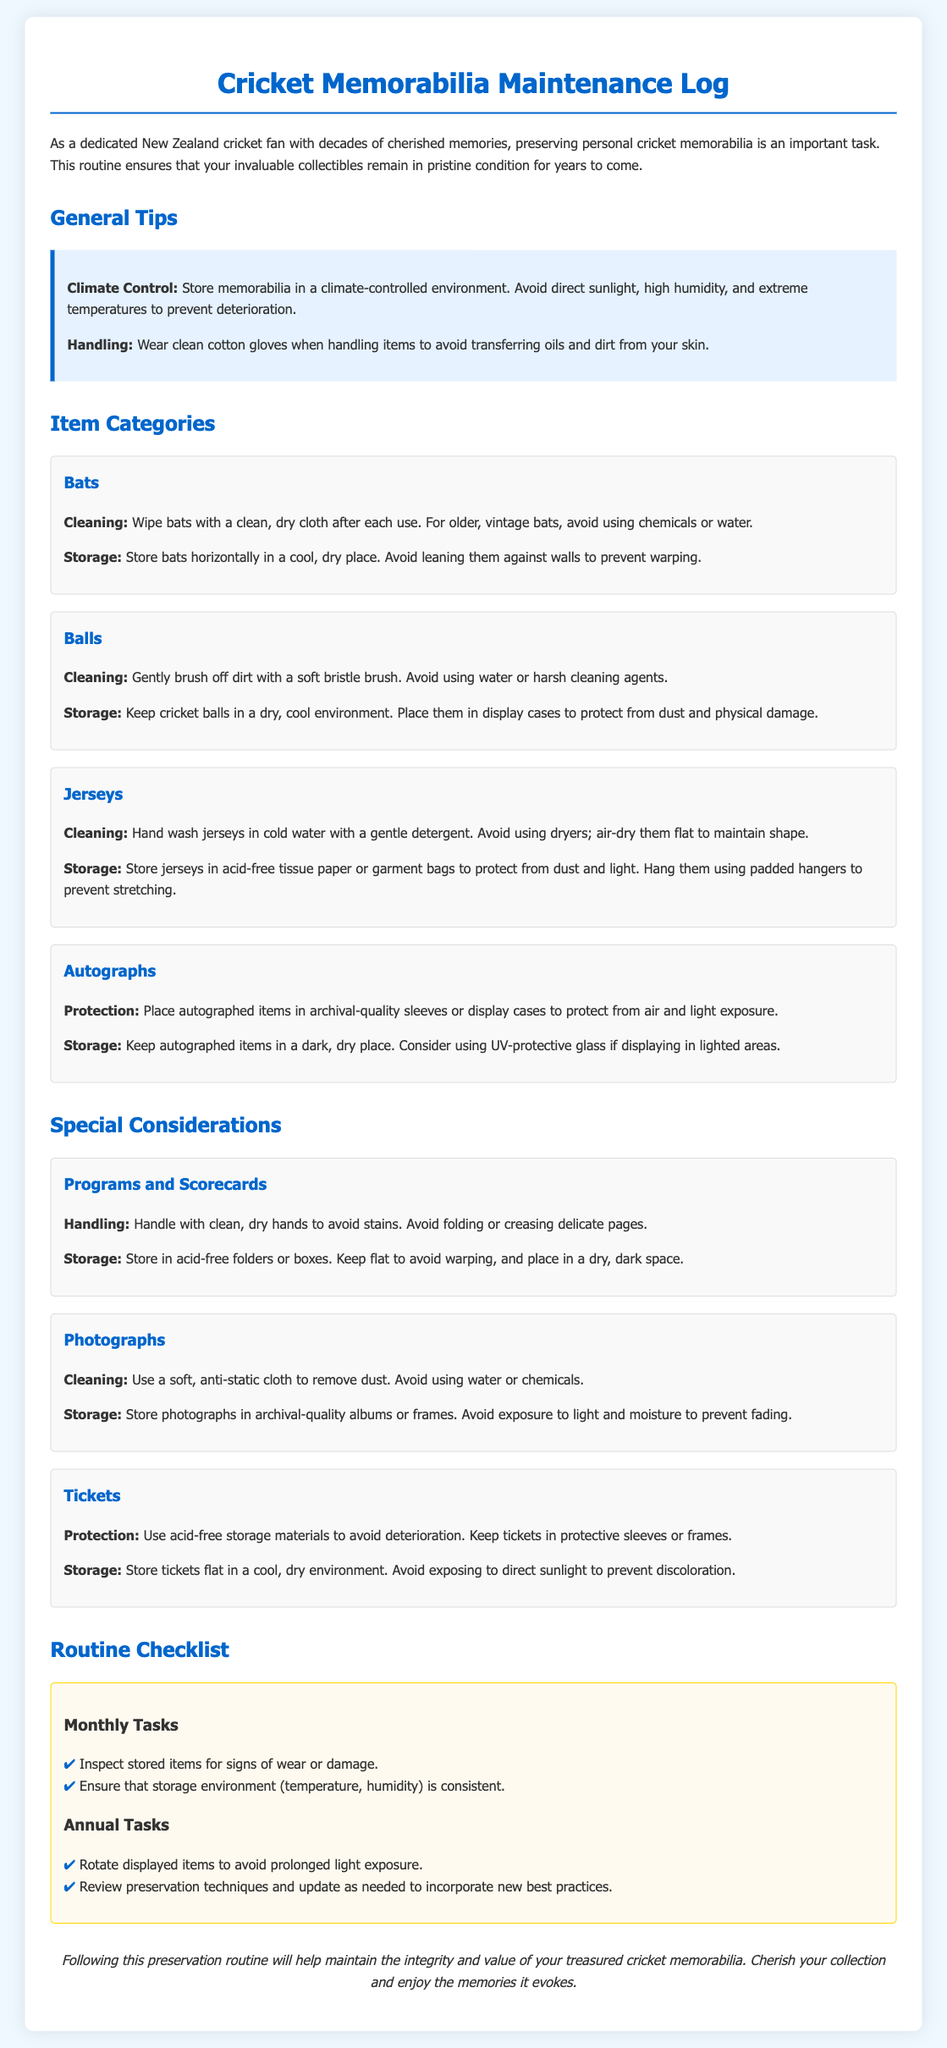What is a key factor for climate control? The document emphasizes the importance of avoiding direct sunlight, high humidity, and extreme temperatures to maintain memorabilia.
Answer: Direct sunlight What should you wear when handling memorabilia? The document advises wearing clean cotton gloves to avoid transferring oils and dirt from your skin.
Answer: Clean cotton gloves What is the recommended storage for bats? The document suggests storing bats horizontally in a cool, dry place and avoiding leaning them against walls.
Answer: Horizontally How often should you inspect stored items? The routine checklist indicates that items should be inspected for signs of wear or damage monthly.
Answer: Monthly What is the preservation technique for jerseys after washing? The document states that jerseys should air-dry flat to maintain their shape after hand washing.
Answer: Air-dry flat What type of storage is recommended for autographs? The document mentions placing autographed items in archival-quality sleeves or display cases for protection.
Answer: Archival-quality sleeves What is a task mentioned for annual maintenance? The checklist includes the task of rotating displayed items to avoid prolonged light exposure annually.
Answer: Rotate displayed items How should photographs be cleaned? The document suggests using a soft, anti-static cloth to remove dust from photographs.
Answer: Soft, anti-static cloth What materials are recommended for storing tickets? The document advises using acid-free storage materials to avoid ticket deterioration.
Answer: Acid-free storage materials 